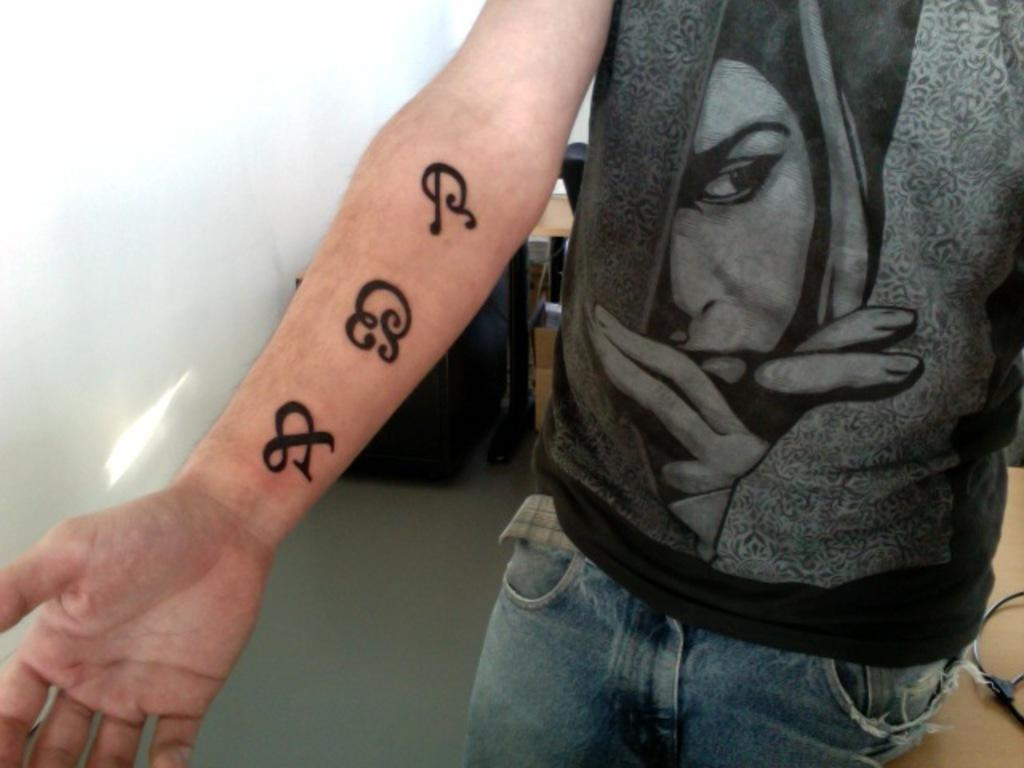What is the main subject of the image? There is a person in the image. What is the person wearing? The person is wearing a black t-shirt and blue jeans. Are there any visible markings or designs on the person? Yes, the person has tattoos on their hand. What can be seen in the background of the image? There are tables in the background of the image. Can you see any bats flying around the person in the image? There are no bats visible in the image. What type of star is shining brightly above the person in the image? There is no star present in the image. 